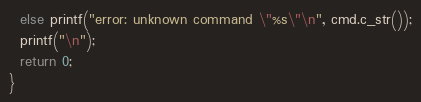<code> <loc_0><loc_0><loc_500><loc_500><_Cuda_>  else printf("error: unknown command \"%s\"\n", cmd.c_str());
  printf("\n");
  return 0;
}
</code> 